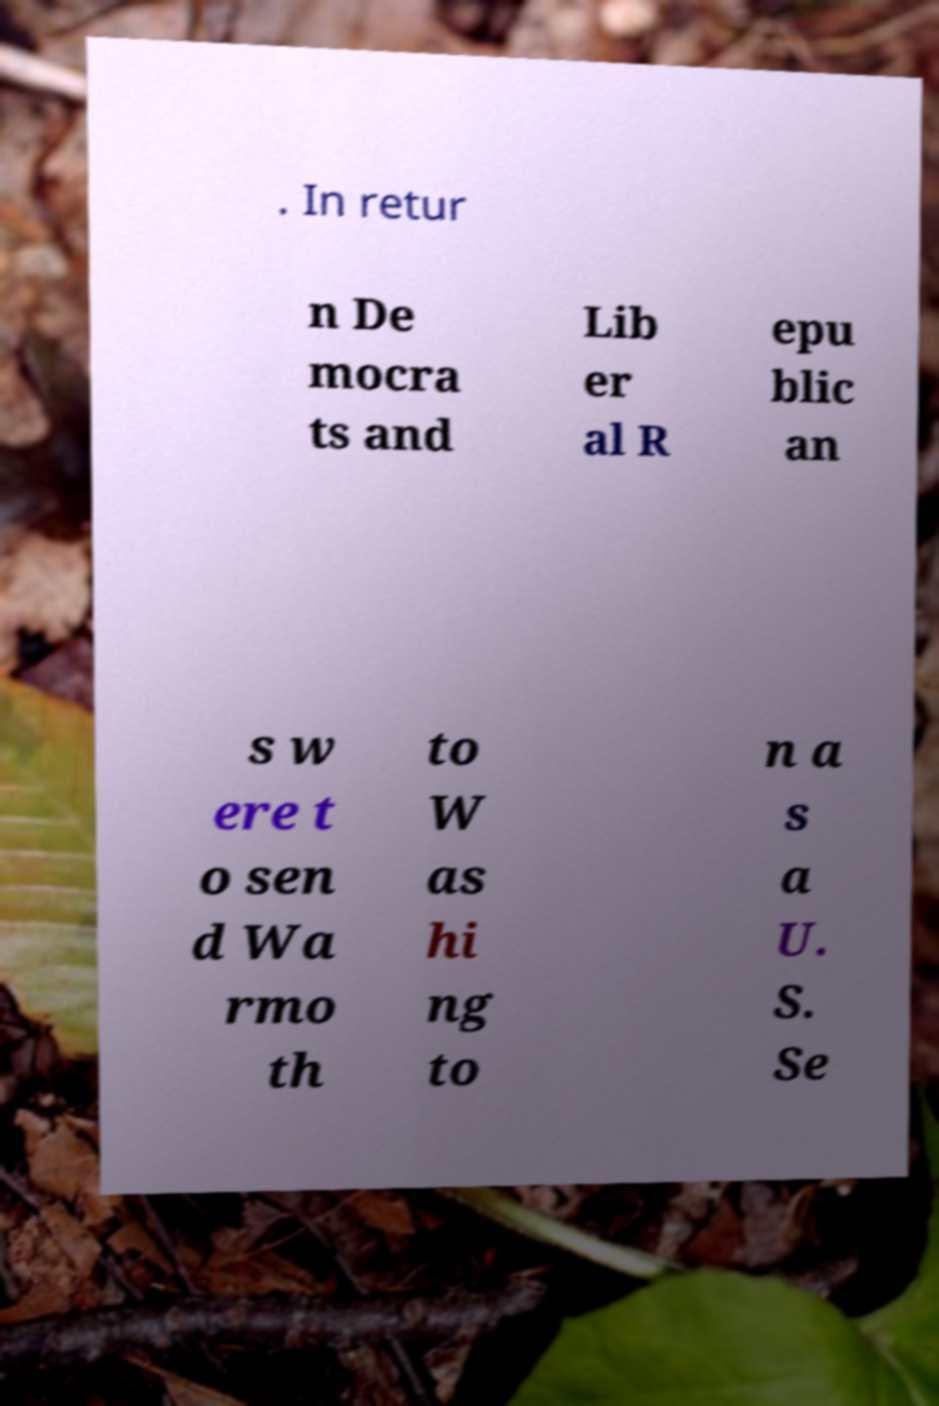Could you extract and type out the text from this image? . In retur n De mocra ts and Lib er al R epu blic an s w ere t o sen d Wa rmo th to W as hi ng to n a s a U. S. Se 